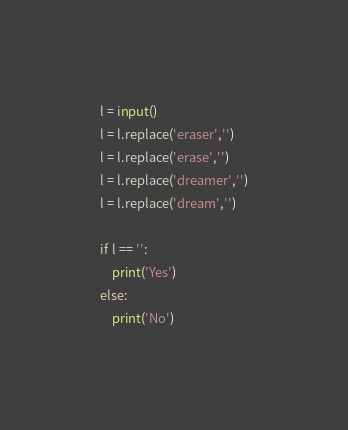Convert code to text. <code><loc_0><loc_0><loc_500><loc_500><_Python_>l = input()
l = l.replace('eraser','')
l = l.replace('erase','')
l = l.replace('dreamer','')
l = l.replace('dream','')

if l == '':
    print('Yes')
else:
    print('No')</code> 